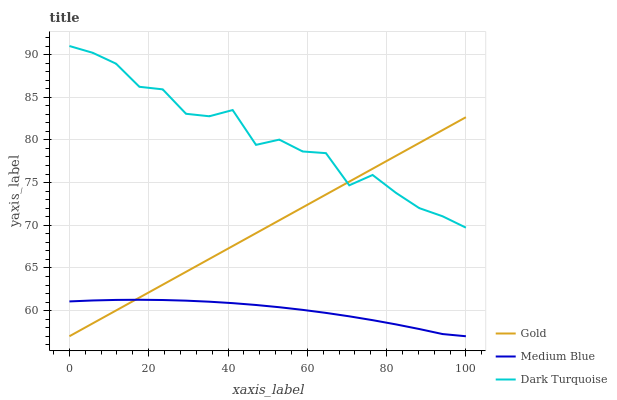Does Medium Blue have the minimum area under the curve?
Answer yes or no. Yes. Does Dark Turquoise have the maximum area under the curve?
Answer yes or no. Yes. Does Gold have the minimum area under the curve?
Answer yes or no. No. Does Gold have the maximum area under the curve?
Answer yes or no. No. Is Gold the smoothest?
Answer yes or no. Yes. Is Dark Turquoise the roughest?
Answer yes or no. Yes. Is Medium Blue the smoothest?
Answer yes or no. No. Is Medium Blue the roughest?
Answer yes or no. No. Does Medium Blue have the lowest value?
Answer yes or no. Yes. Does Dark Turquoise have the highest value?
Answer yes or no. Yes. Does Gold have the highest value?
Answer yes or no. No. Is Medium Blue less than Dark Turquoise?
Answer yes or no. Yes. Is Dark Turquoise greater than Medium Blue?
Answer yes or no. Yes. Does Gold intersect Medium Blue?
Answer yes or no. Yes. Is Gold less than Medium Blue?
Answer yes or no. No. Is Gold greater than Medium Blue?
Answer yes or no. No. Does Medium Blue intersect Dark Turquoise?
Answer yes or no. No. 